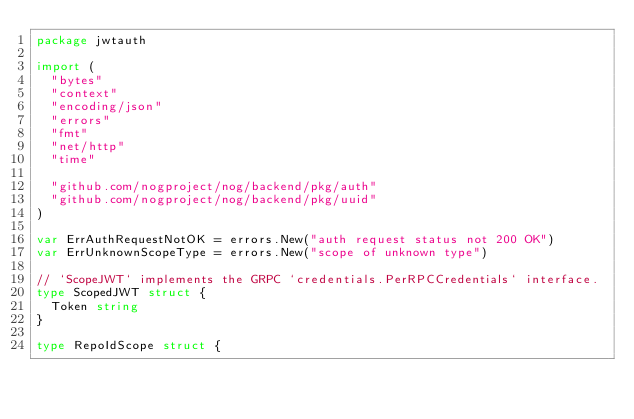Convert code to text. <code><loc_0><loc_0><loc_500><loc_500><_Go_>package jwtauth

import (
	"bytes"
	"context"
	"encoding/json"
	"errors"
	"fmt"
	"net/http"
	"time"

	"github.com/nogproject/nog/backend/pkg/auth"
	"github.com/nogproject/nog/backend/pkg/uuid"
)

var ErrAuthRequestNotOK = errors.New("auth request status not 200 OK")
var ErrUnknownScopeType = errors.New("scope of unknown type")

// `ScopeJWT` implements the GRPC `credentials.PerRPCCredentials` interface.
type ScopedJWT struct {
	Token string
}

type RepoIdScope struct {</code> 